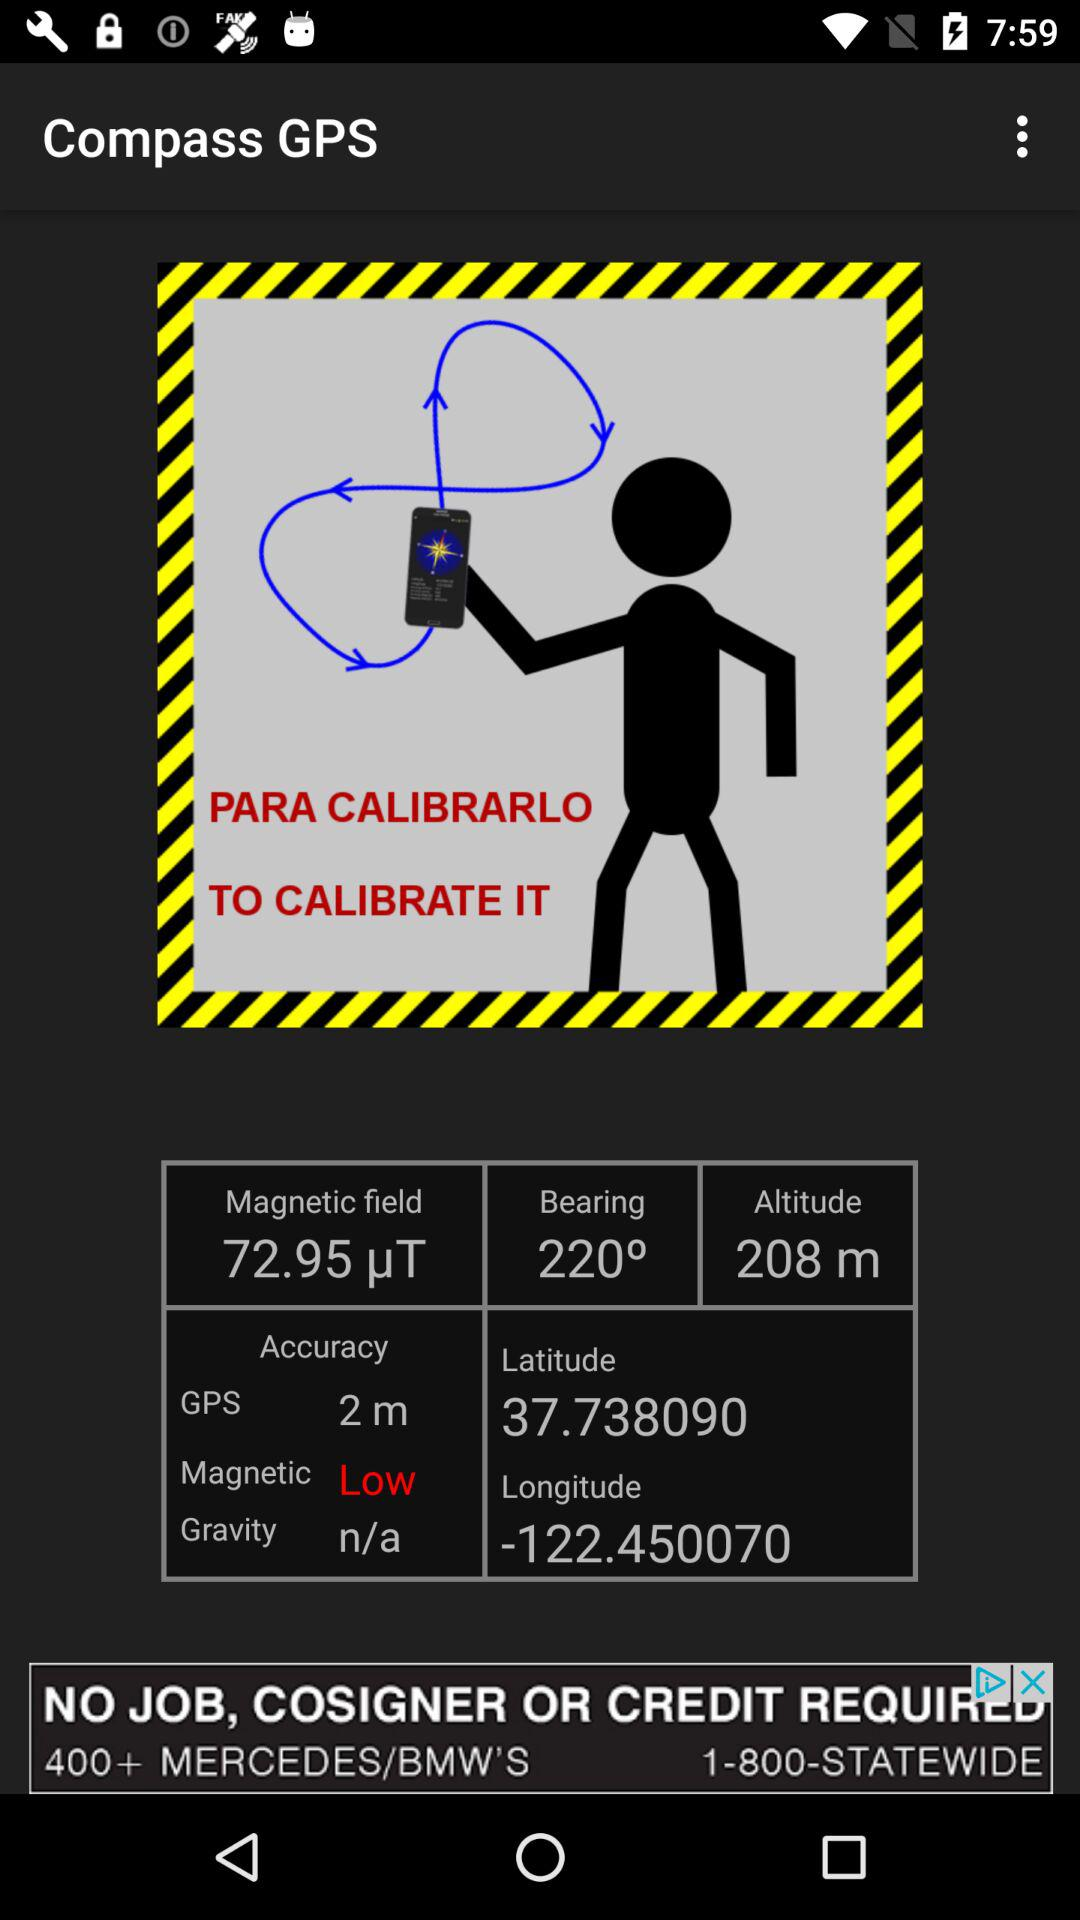What is the bearing angle? The bearing angle is 219°. 